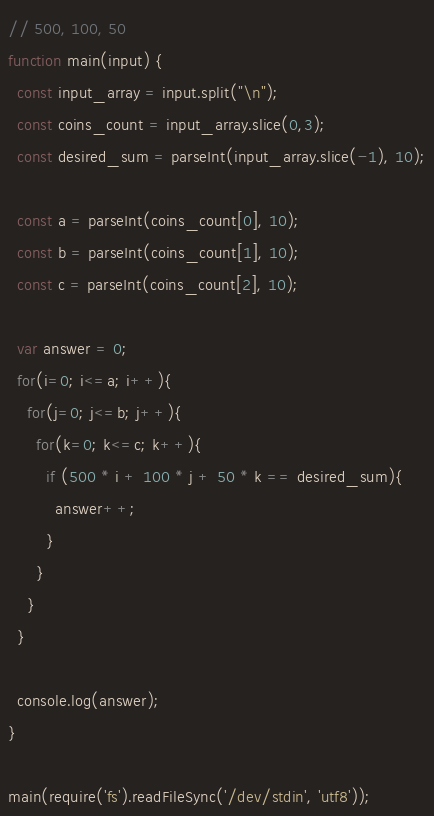Convert code to text. <code><loc_0><loc_0><loc_500><loc_500><_JavaScript_>// 500, 100, 50
function main(input) {
  const input_array = input.split("\n");
  const coins_count = input_array.slice(0,3);
  const desired_sum = parseInt(input_array.slice(-1), 10);

  const a = parseInt(coins_count[0], 10);
  const b = parseInt(coins_count[1], 10);
  const c = parseInt(coins_count[2], 10);
  
  var answer = 0;
  for(i=0; i<=a; i++){
    for(j=0; j<=b; j++){
      for(k=0; k<=c; k++){
        if (500 * i + 100 * j + 50 * k == desired_sum){
          answer++;
        }
      }
    }
  }
  
  console.log(answer);
}
 
main(require('fs').readFileSync('/dev/stdin', 'utf8'));</code> 